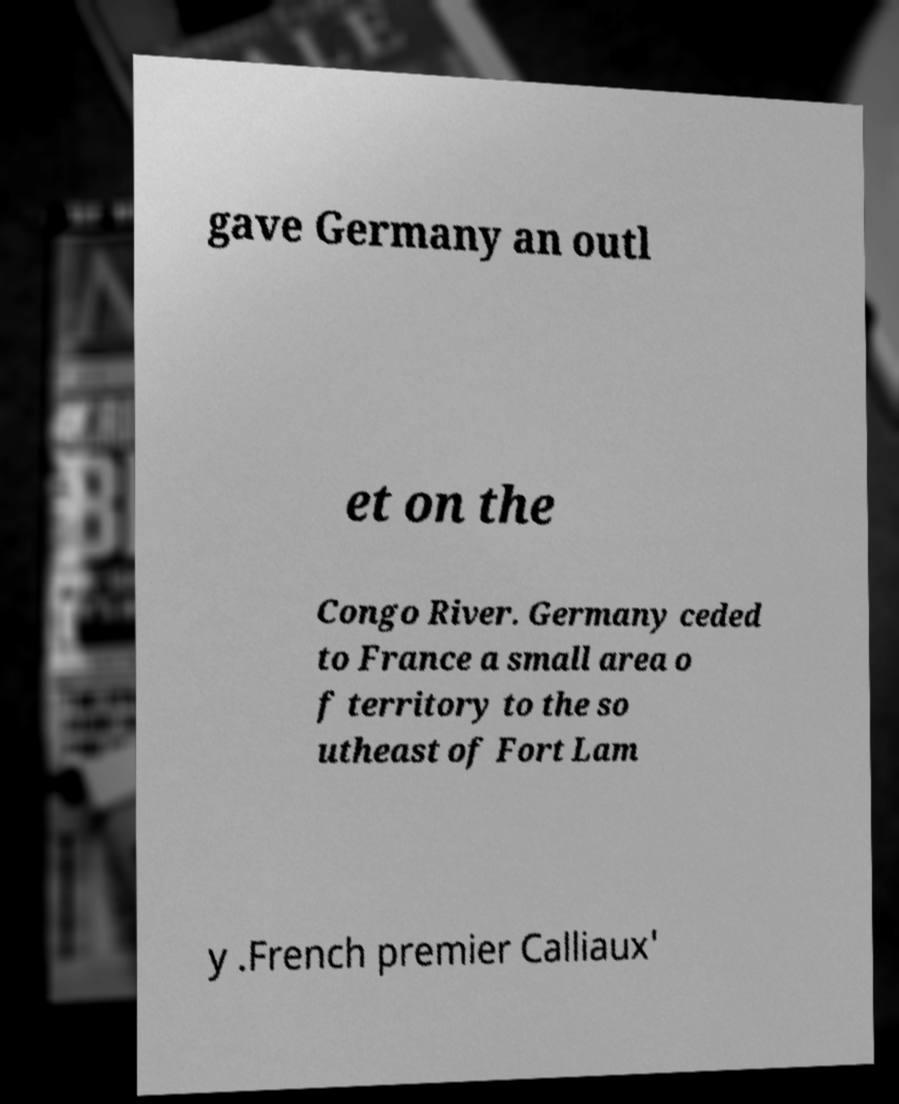There's text embedded in this image that I need extracted. Can you transcribe it verbatim? gave Germany an outl et on the Congo River. Germany ceded to France a small area o f territory to the so utheast of Fort Lam y .French premier Calliaux' 